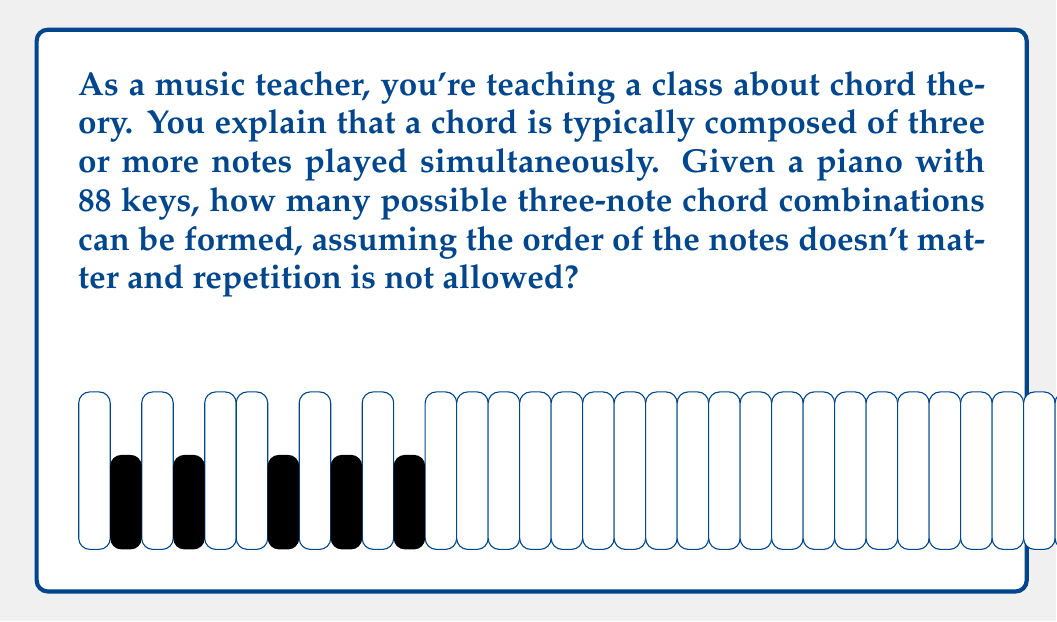Solve this math problem. To solve this problem, we need to use the combination formula. We're selecting 3 notes from 88 available keys, where the order doesn't matter and repetition is not allowed.

The formula for combinations is:

$$ C(n,r) = \frac{n!}{r!(n-r)!} $$

Where:
$n$ is the total number of items to choose from (88 keys)
$r$ is the number of items being chosen (3 notes)

Plugging in our values:

$$ C(88,3) = \frac{88!}{3!(88-3)!} = \frac{88!}{3!85!} $$

Simplifying:

$$ \frac{88 \cdot 87 \cdot 86 \cdot 85!}{3 \cdot 2 \cdot 1 \cdot 85!} $$

The 85! cancels out in the numerator and denominator:

$$ \frac{88 \cdot 87 \cdot 86}{3 \cdot 2 \cdot 1} = \frac{658,008}{6} = 109,668 $$

Therefore, there are 109,668 possible three-note chord combinations on an 88-key piano.
Answer: 109,668 